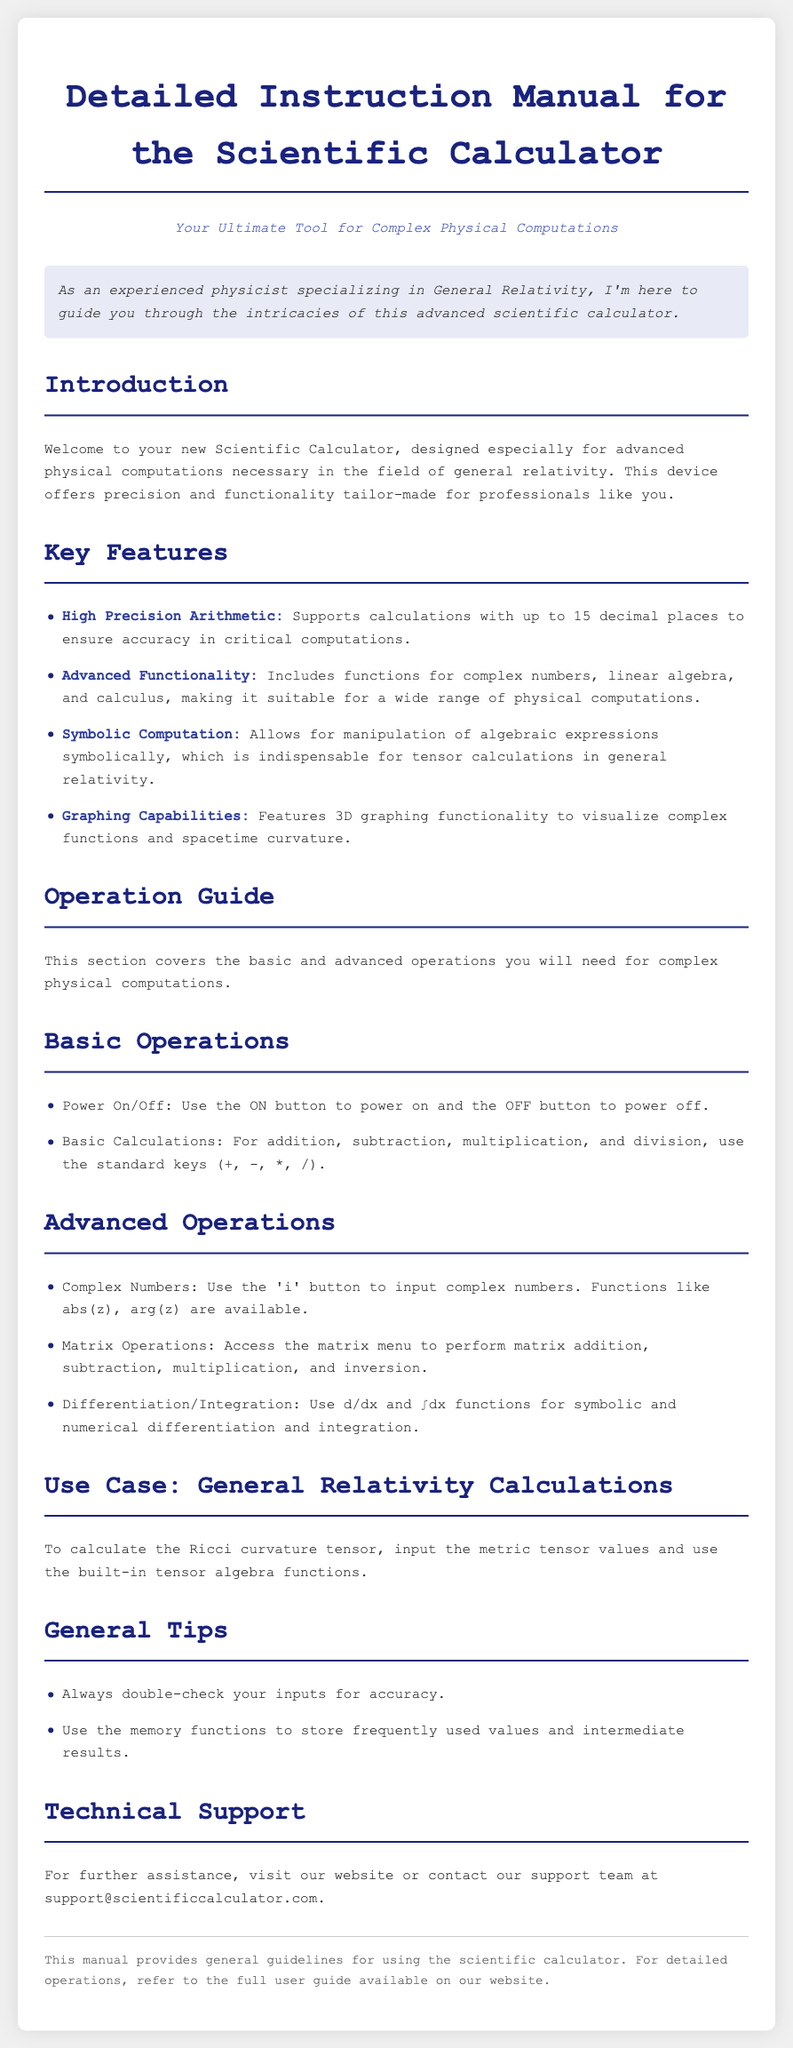What is the title of the document? The title of the document is indicated at the top of the rendered document.
Answer: Detailed Instruction Manual for the Scientific Calculator What is the main intended use of the scientific calculator? The main intended use is described in the introduction section of the document.
Answer: Complex Physical Computations How many decimal places does the calculator support for high precision arithmetic? The relevant feature is mentioned under the key features section.
Answer: 15 decimal places What button do you use to power on the calculator? This information is found in the basic operations section.
Answer: ON button What function should be used to calculate complex numbers? This function is described under the advanced operations section.
Answer: 'i' button What is one example of its graphing capability? The capabilities are listed under key features of the document.
Answer: 3D graphing functionality For what specific calculation is the calculator particularly useful in general relativity? This is mentioned in the use case section of the document.
Answer: Ricci curvature tensor What type of support is available for the calculator? This is detailed in the technical support section of the document.
Answer: Contact support team What kind of computations can the symbolic computation feature assist with? The purpose of this feature is explained in the key features section.
Answer: Tensor calculations 